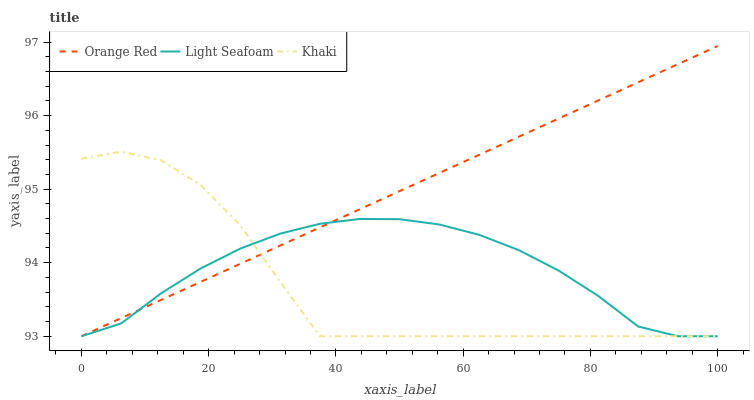Does Khaki have the minimum area under the curve?
Answer yes or no. Yes. Does Orange Red have the maximum area under the curve?
Answer yes or no. Yes. Does Orange Red have the minimum area under the curve?
Answer yes or no. No. Does Khaki have the maximum area under the curve?
Answer yes or no. No. Is Orange Red the smoothest?
Answer yes or no. Yes. Is Khaki the roughest?
Answer yes or no. Yes. Is Khaki the smoothest?
Answer yes or no. No. Is Orange Red the roughest?
Answer yes or no. No. Does Light Seafoam have the lowest value?
Answer yes or no. Yes. Does Orange Red have the highest value?
Answer yes or no. Yes. Does Khaki have the highest value?
Answer yes or no. No. Does Khaki intersect Orange Red?
Answer yes or no. Yes. Is Khaki less than Orange Red?
Answer yes or no. No. Is Khaki greater than Orange Red?
Answer yes or no. No. 